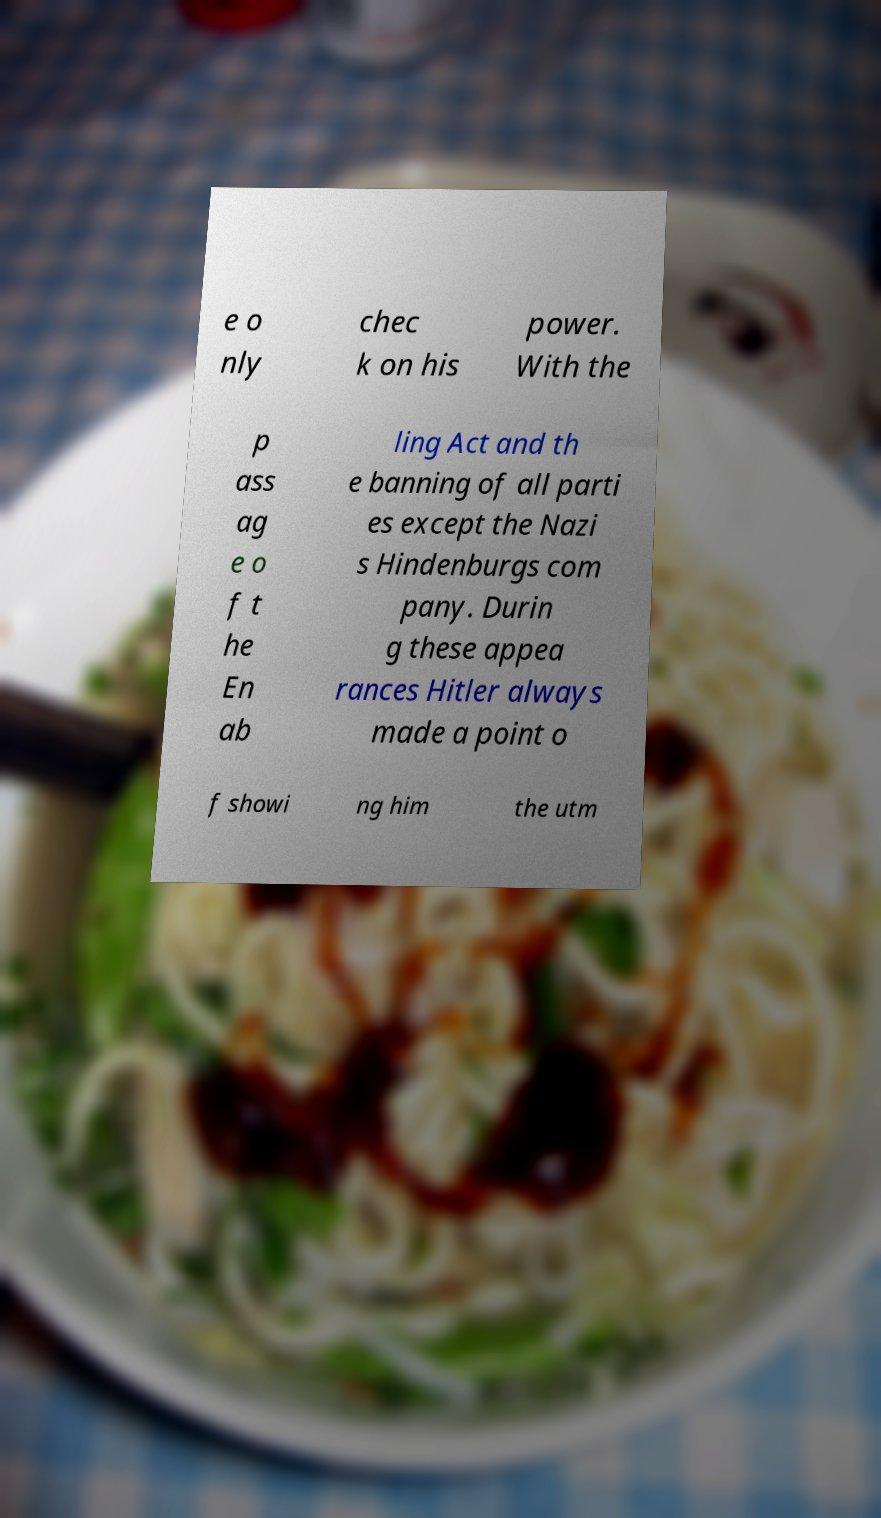What messages or text are displayed in this image? I need them in a readable, typed format. e o nly chec k on his power. With the p ass ag e o f t he En ab ling Act and th e banning of all parti es except the Nazi s Hindenburgs com pany. Durin g these appea rances Hitler always made a point o f showi ng him the utm 